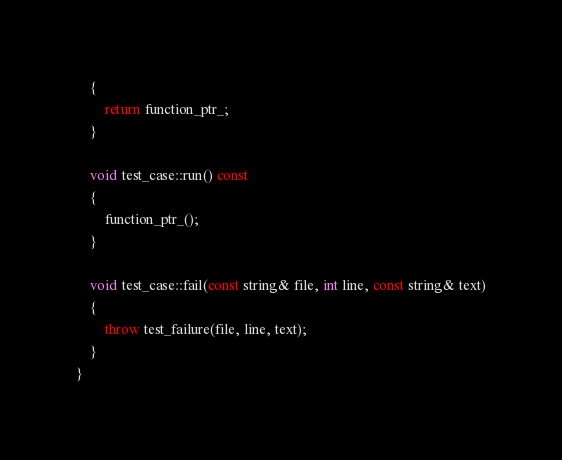Convert code to text. <code><loc_0><loc_0><loc_500><loc_500><_C++_>    {
        return function_ptr_;
    }

    void test_case::run() const
    {
        function_ptr_();
    }

    void test_case::fail(const string& file, int line, const string& text)
    {
        throw test_failure(file, line, text);
    }
}
</code> 